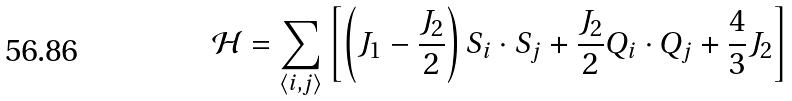Convert formula to latex. <formula><loc_0><loc_0><loc_500><loc_500>\mathcal { H } = \sum _ { \langle i , j \rangle } \left [ \left ( J _ { 1 } - \frac { J _ { 2 } } { 2 } \right ) { S } _ { i } \cdot { S } _ { j } + \frac { J _ { 2 } } { 2 } { Q } _ { i } \cdot { Q } _ { j } + \frac { 4 } { 3 } J _ { 2 } \right ]</formula> 